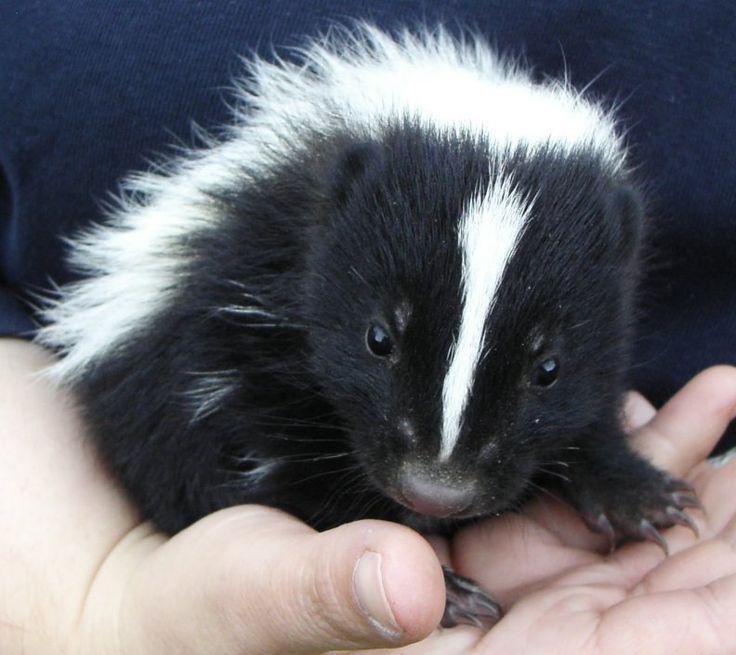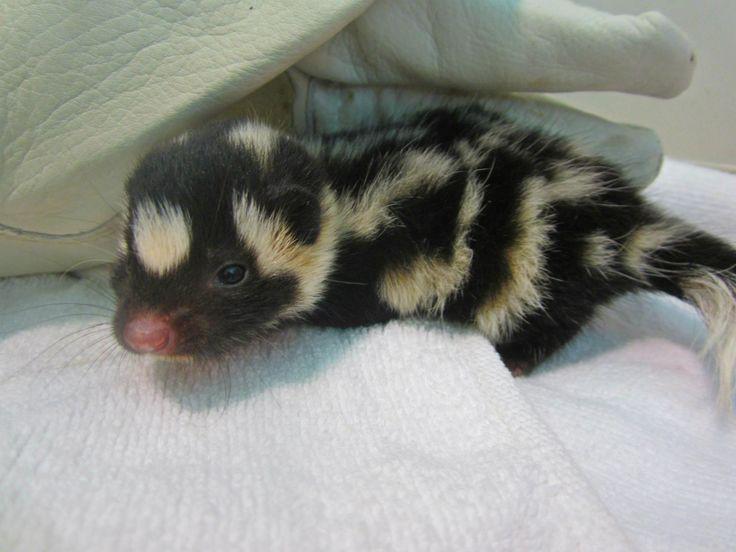The first image is the image on the left, the second image is the image on the right. Given the left and right images, does the statement "Only two young skunks are shown and no other animals are visible." hold true? Answer yes or no. Yes. The first image is the image on the left, the second image is the image on the right. Given the left and right images, does the statement "There are just two skunks and no other animals." hold true? Answer yes or no. Yes. 